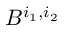Convert formula to latex. <formula><loc_0><loc_0><loc_500><loc_500>B ^ { i _ { 1 } , i _ { 2 } }</formula> 